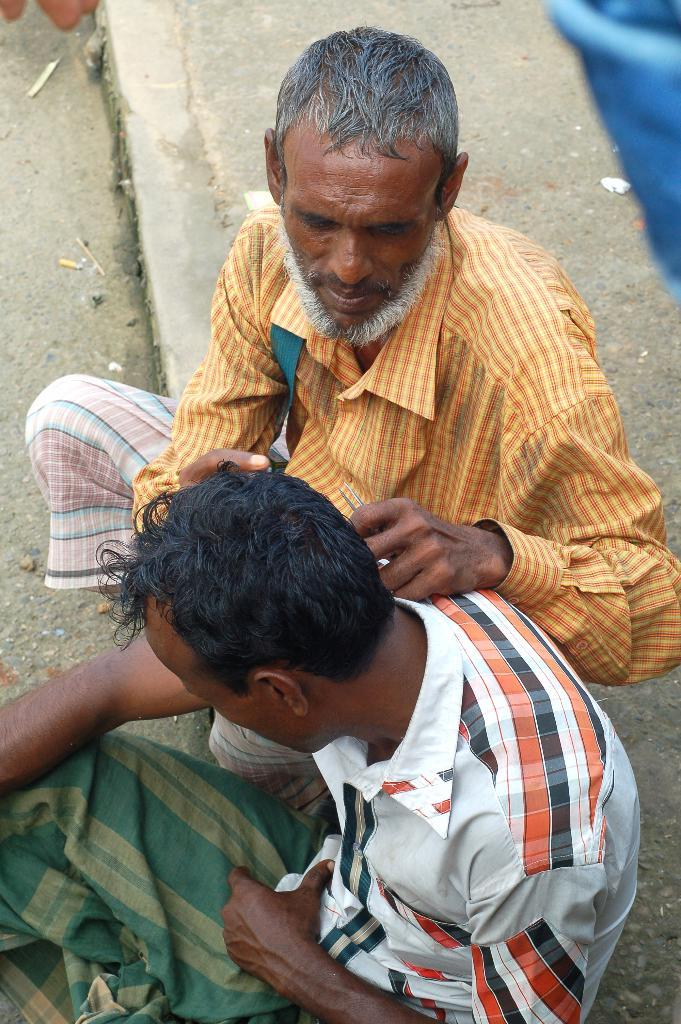How many people are in the image? There are two persons in the image. What are the two persons doing in the image? The two persons are sitting on the ground. Can you describe one of the persons in the image? One of the persons is a man. What is the man wearing in the image? The man is wearing a shirt. What thoughts can be seen on the faces of the persons in the image? There are no thoughts visible on the faces of the persons in the image. --- Facts: 1. There is a car in the image. 2. The car is red. 3. The car has four wheels. 4. The car is parked on the street. Absurd Topics: unicorn, rainbow, magic Conversation: What is the main subject in the image? The main subject in the image is a car. Can you describe the car in the image? Yes, the car is red and has four wheels. Where is the car located in the image? The car is parked on the street. Reasoning: Let's think step by step in order to produce the conversation. We start by identifying the main subject of the image, which is the car. Next, we describe specific features of the car, such as its color and the number of wheels it has. Then, we observe the location of the car in the image, which is parked on the street. Absurd Question/Answer: Can you see a unicorn in the image? No, there is no unicorn present in the image. --- Facts: 1. There is a group of people in the image. 2. The people are wearing hats. 3. The people are holding hands. 4. The people are standing in a circle. Absurd Topics: elephant, giraffe, zebra Conversation: How many people are in the image? There is a group of people in the image. What are the people wearing in the image? The people are wearing hats. What are the people doing in the image? The people are holding hands. How are the people positioned in the image? The people are standing in a circle. Reasoning: Let's think step by step in order to produce the conversation. We start by identifying the number of people in the image, which is a group of people. Next, we describe what the people are wearing, which are hats. Then, we observe the actions of the people, noting that they are holding hands. Finally, we describe the positioning of the people in the image, which is standing in a circle. Absurd Question/Answer: Can you see a giraffe in the image? No, there is no giraffe present in the image. --- Facts: 1. There is a dog in the image. 2. The dog is sitting on a chair. 3. The dog is wearing a bow 